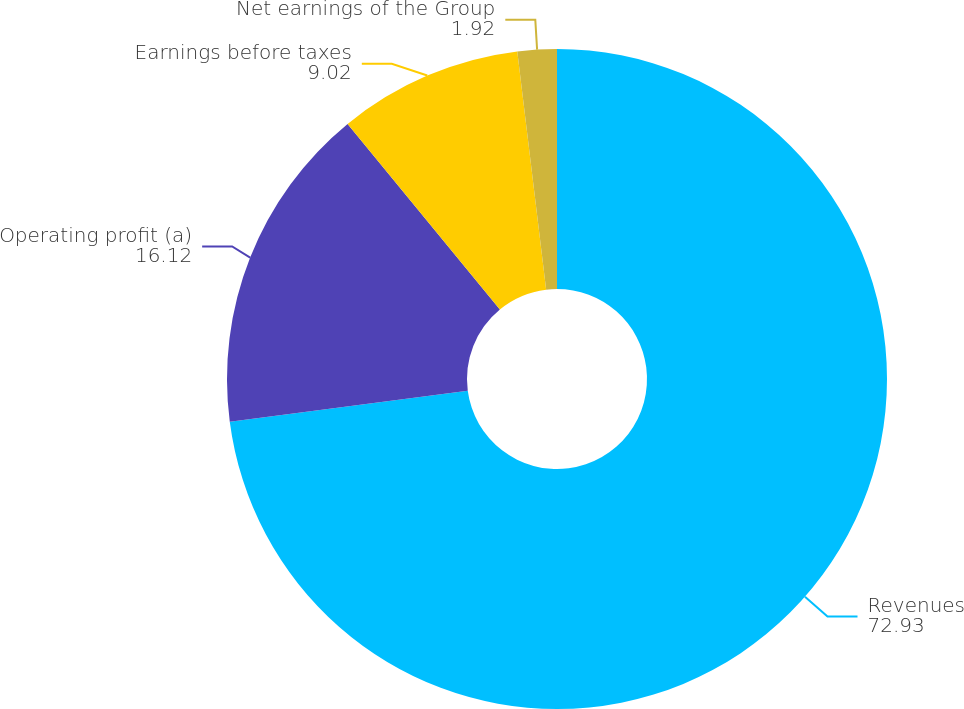<chart> <loc_0><loc_0><loc_500><loc_500><pie_chart><fcel>Revenues<fcel>Operating profit (a)<fcel>Earnings before taxes<fcel>Net earnings of the Group<nl><fcel>72.93%<fcel>16.12%<fcel>9.02%<fcel>1.92%<nl></chart> 